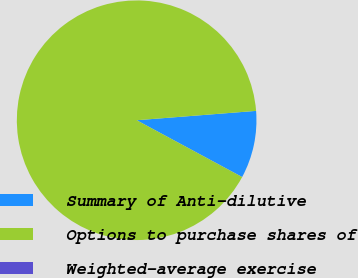Convert chart to OTSL. <chart><loc_0><loc_0><loc_500><loc_500><pie_chart><fcel>Summary of Anti-dilutive<fcel>Options to purchase shares of<fcel>Weighted-average exercise<nl><fcel>9.1%<fcel>90.9%<fcel>0.01%<nl></chart> 